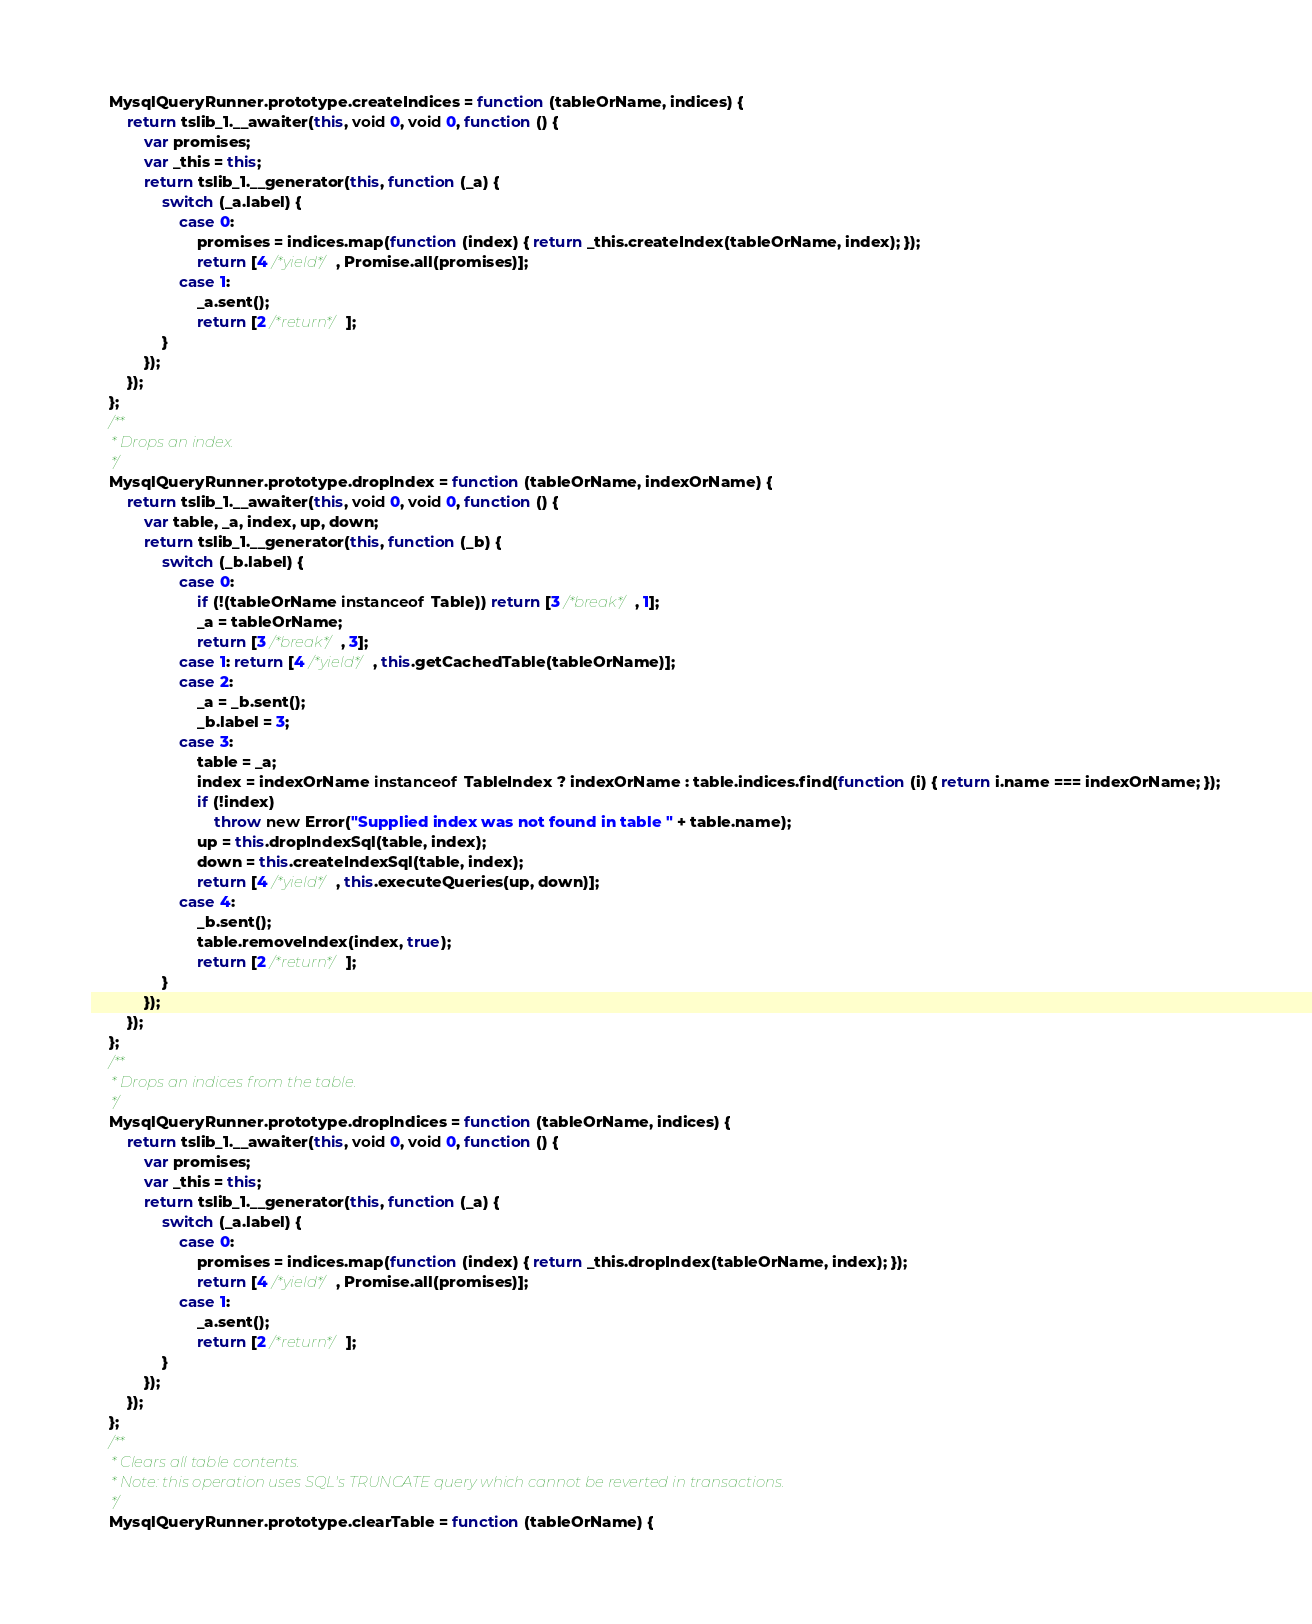<code> <loc_0><loc_0><loc_500><loc_500><_JavaScript_>    MysqlQueryRunner.prototype.createIndices = function (tableOrName, indices) {
        return tslib_1.__awaiter(this, void 0, void 0, function () {
            var promises;
            var _this = this;
            return tslib_1.__generator(this, function (_a) {
                switch (_a.label) {
                    case 0:
                        promises = indices.map(function (index) { return _this.createIndex(tableOrName, index); });
                        return [4 /*yield*/, Promise.all(promises)];
                    case 1:
                        _a.sent();
                        return [2 /*return*/];
                }
            });
        });
    };
    /**
     * Drops an index.
     */
    MysqlQueryRunner.prototype.dropIndex = function (tableOrName, indexOrName) {
        return tslib_1.__awaiter(this, void 0, void 0, function () {
            var table, _a, index, up, down;
            return tslib_1.__generator(this, function (_b) {
                switch (_b.label) {
                    case 0:
                        if (!(tableOrName instanceof Table)) return [3 /*break*/, 1];
                        _a = tableOrName;
                        return [3 /*break*/, 3];
                    case 1: return [4 /*yield*/, this.getCachedTable(tableOrName)];
                    case 2:
                        _a = _b.sent();
                        _b.label = 3;
                    case 3:
                        table = _a;
                        index = indexOrName instanceof TableIndex ? indexOrName : table.indices.find(function (i) { return i.name === indexOrName; });
                        if (!index)
                            throw new Error("Supplied index was not found in table " + table.name);
                        up = this.dropIndexSql(table, index);
                        down = this.createIndexSql(table, index);
                        return [4 /*yield*/, this.executeQueries(up, down)];
                    case 4:
                        _b.sent();
                        table.removeIndex(index, true);
                        return [2 /*return*/];
                }
            });
        });
    };
    /**
     * Drops an indices from the table.
     */
    MysqlQueryRunner.prototype.dropIndices = function (tableOrName, indices) {
        return tslib_1.__awaiter(this, void 0, void 0, function () {
            var promises;
            var _this = this;
            return tslib_1.__generator(this, function (_a) {
                switch (_a.label) {
                    case 0:
                        promises = indices.map(function (index) { return _this.dropIndex(tableOrName, index); });
                        return [4 /*yield*/, Promise.all(promises)];
                    case 1:
                        _a.sent();
                        return [2 /*return*/];
                }
            });
        });
    };
    /**
     * Clears all table contents.
     * Note: this operation uses SQL's TRUNCATE query which cannot be reverted in transactions.
     */
    MysqlQueryRunner.prototype.clearTable = function (tableOrName) {</code> 